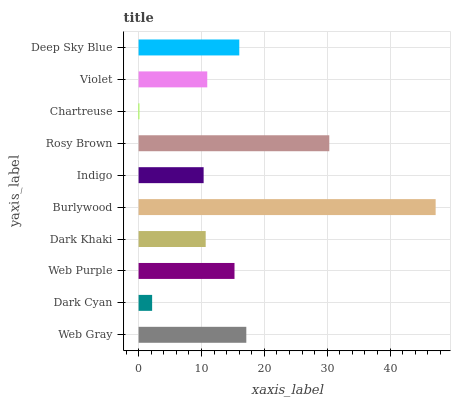Is Chartreuse the minimum?
Answer yes or no. Yes. Is Burlywood the maximum?
Answer yes or no. Yes. Is Dark Cyan the minimum?
Answer yes or no. No. Is Dark Cyan the maximum?
Answer yes or no. No. Is Web Gray greater than Dark Cyan?
Answer yes or no. Yes. Is Dark Cyan less than Web Gray?
Answer yes or no. Yes. Is Dark Cyan greater than Web Gray?
Answer yes or no. No. Is Web Gray less than Dark Cyan?
Answer yes or no. No. Is Web Purple the high median?
Answer yes or no. Yes. Is Violet the low median?
Answer yes or no. Yes. Is Dark Khaki the high median?
Answer yes or no. No. Is Burlywood the low median?
Answer yes or no. No. 